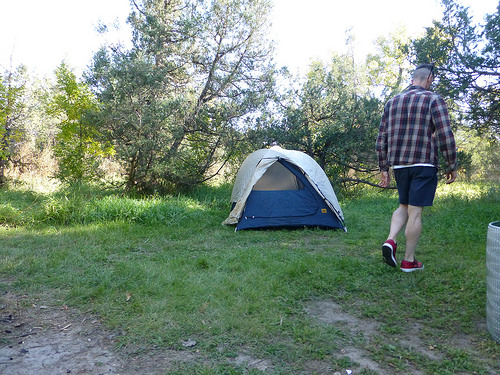<image>
Is the man to the left of the tent? No. The man is not to the left of the tent. From this viewpoint, they have a different horizontal relationship. 